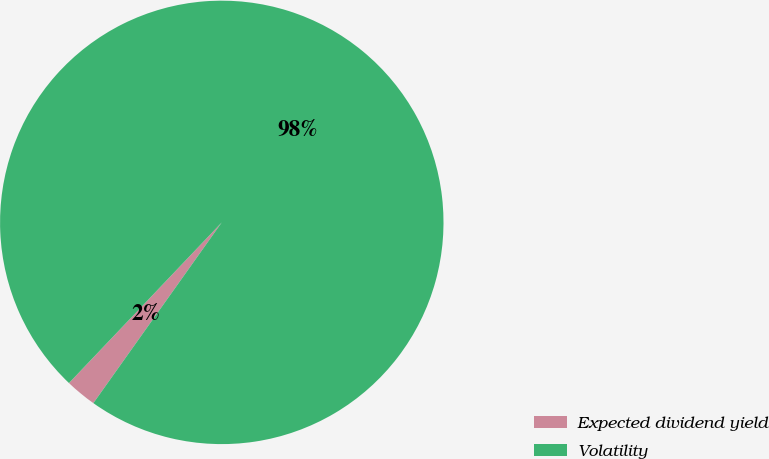<chart> <loc_0><loc_0><loc_500><loc_500><pie_chart><fcel>Expected dividend yield<fcel>Volatility<nl><fcel>2.27%<fcel>97.73%<nl></chart> 